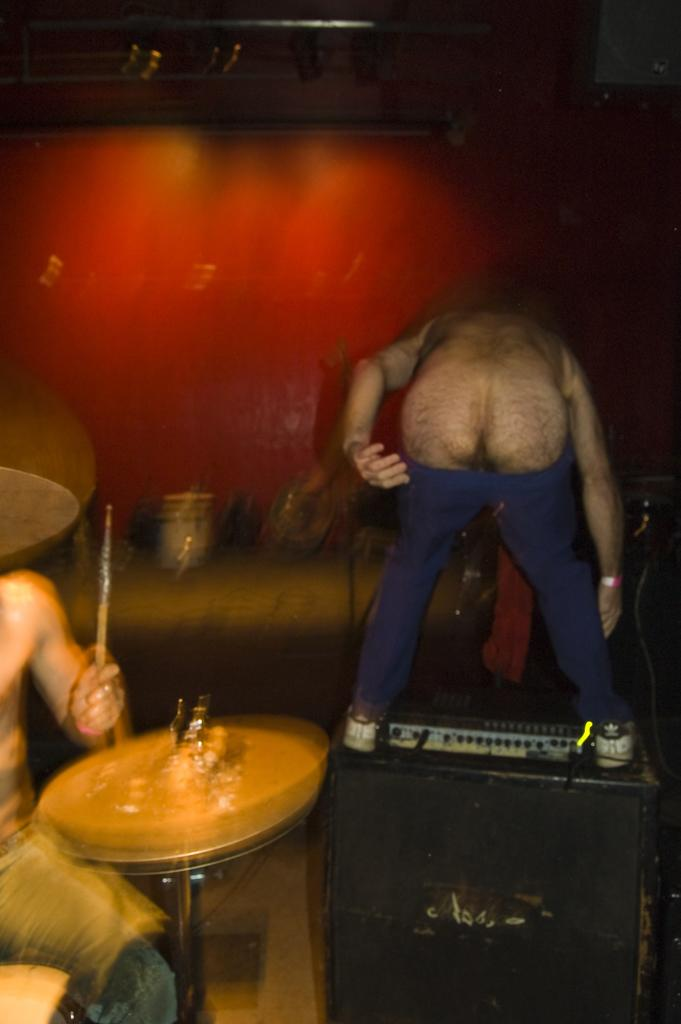What is the main activity being performed in the image? There is a person playing drums in the image. Where is the person playing drums located? The person playing drums is on the right side of the image. What is another person doing in the image? There is a person bending in the image. What can be observed about the person bending's clothing? The person bending is wearing blue trousers. How would you describe the background of the image? The background of the image is blurred. What type of watch is the person wearing in the image? There is no watch visible on any person in the image. What kind of cloth is being used to make the drum set in the image? The image does not provide information about the materials used to make the drum set. 